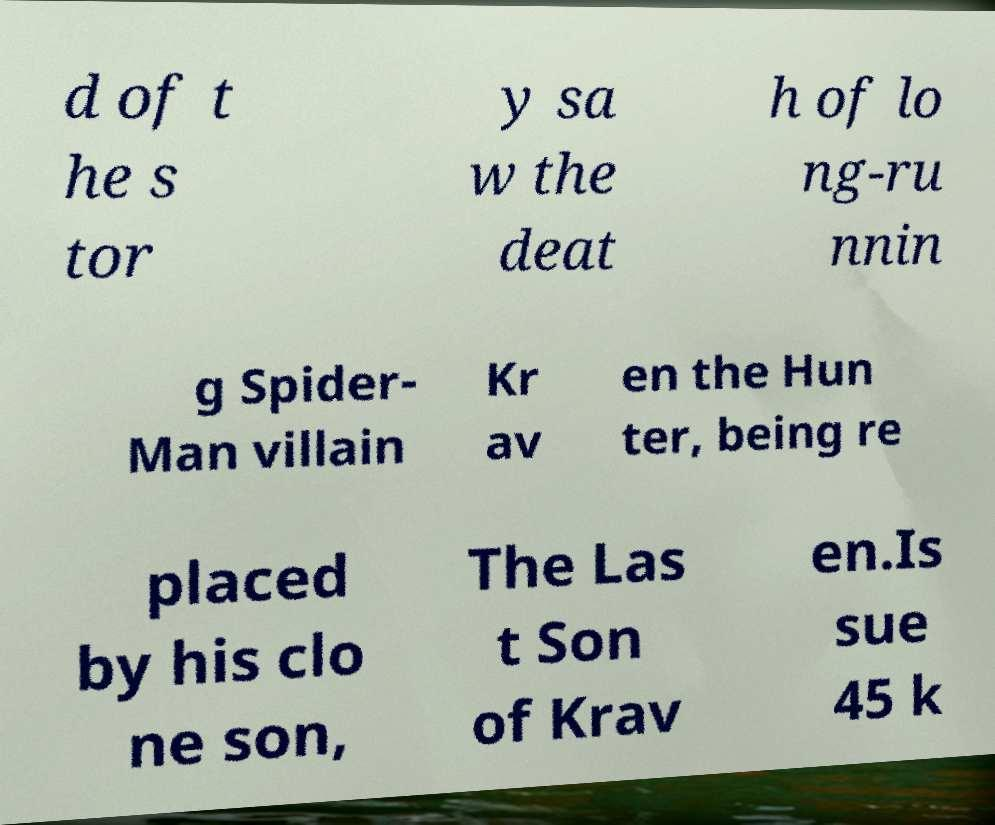Could you assist in decoding the text presented in this image and type it out clearly? d of t he s tor y sa w the deat h of lo ng-ru nnin g Spider- Man villain Kr av en the Hun ter, being re placed by his clo ne son, The Las t Son of Krav en.Is sue 45 k 